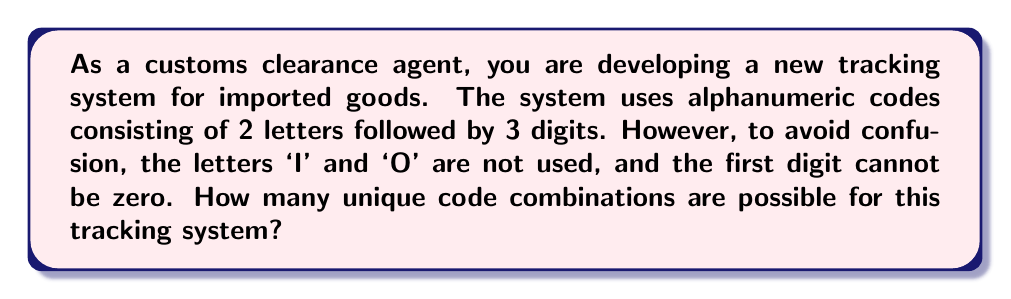Show me your answer to this math problem. Let's break this down step-by-step:

1) For the letters:
   - We have 26 letters in the alphabet.
   - We can't use 'I' and 'O', so we have 24 choices for each letter.
   - We need to choose 2 letters.
   - This is a permutation with repetition allowed.
   - Number of letter combinations: $24 \times 24 = 576$

2) For the digits:
   - We have 10 digits (0-9).
   - The first digit can't be zero, so we have 9 choices for the first digit.
   - For the second and third digits, we can use any digit from 0-9.
   - Number of digit combinations: $9 \times 10 \times 10 = 900$

3) To get the total number of unique combinations, we multiply the number of letter combinations by the number of digit combinations:

   $$ 576 \times 900 = 518,400 $$

Therefore, the total number of unique code combinations is 518,400.
Answer: 518,400 unique code combinations 